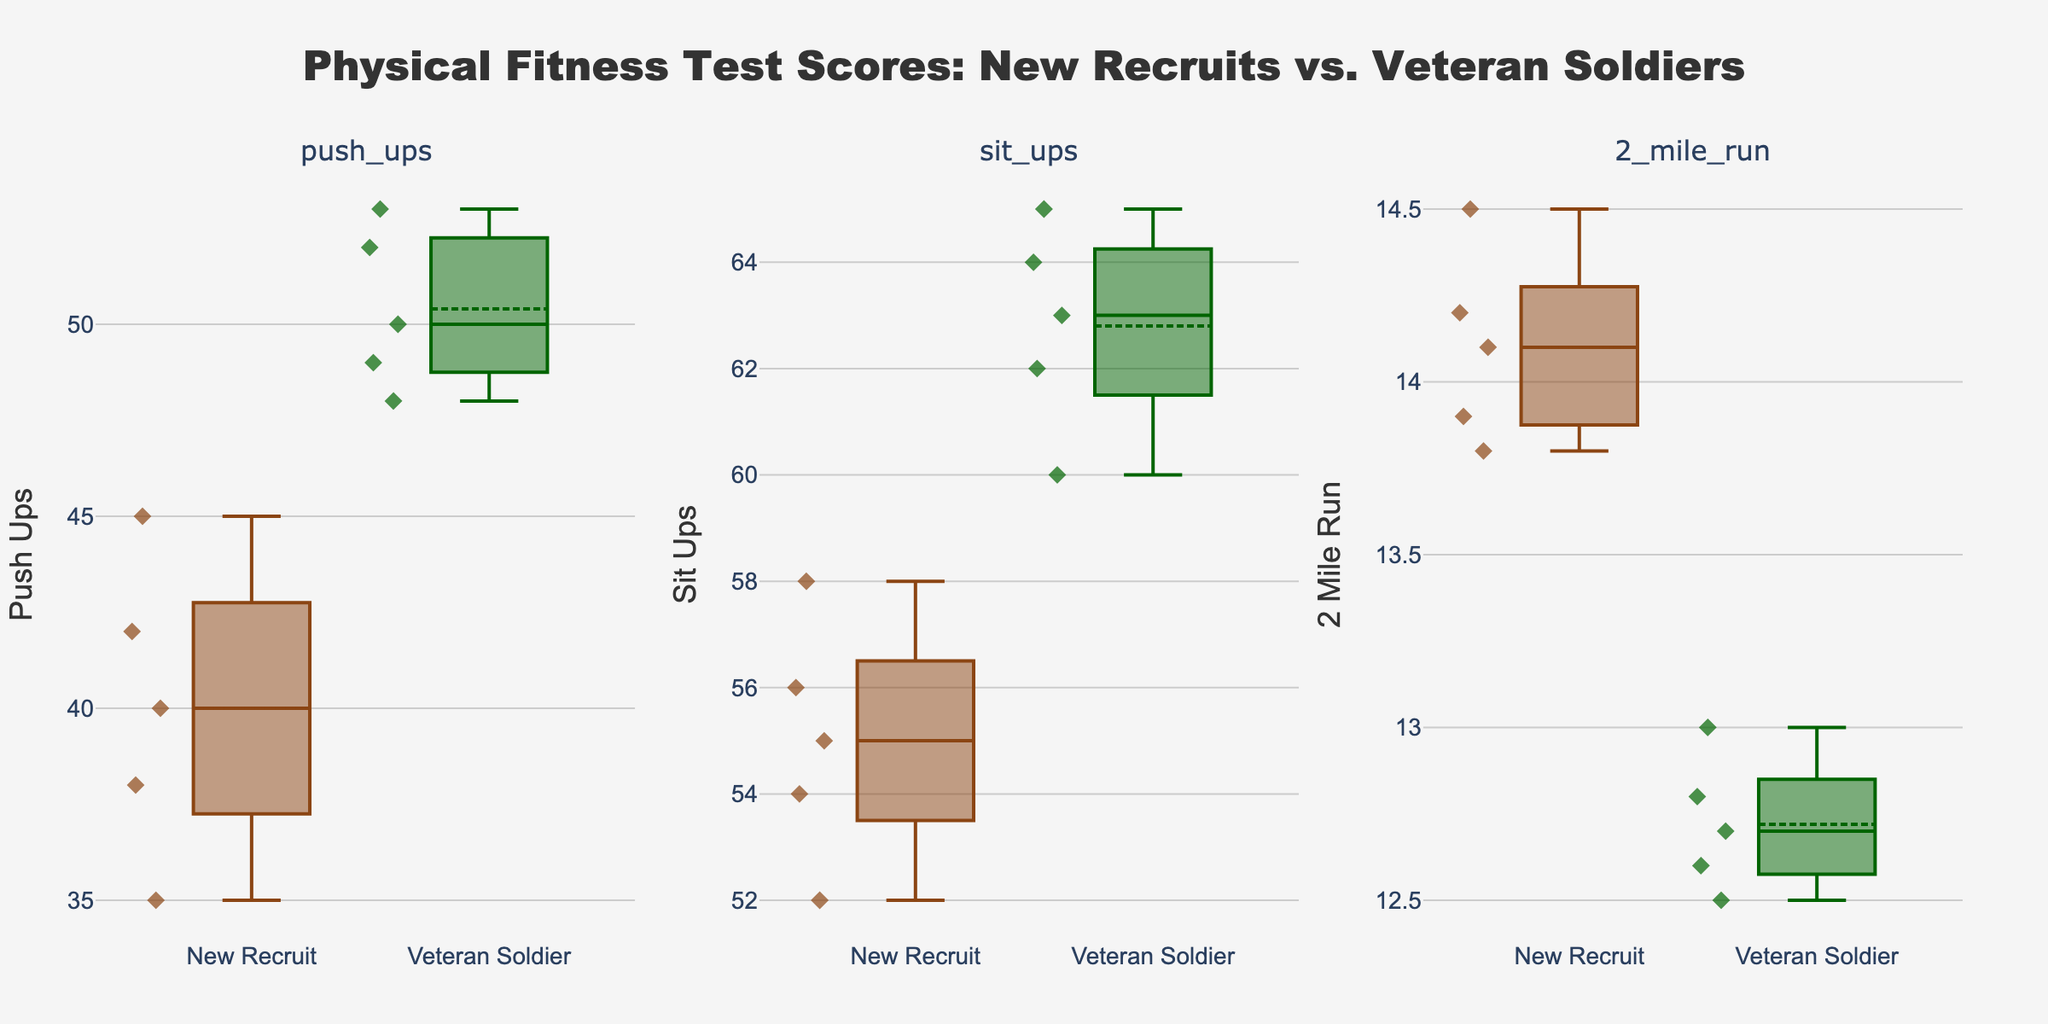What is the main title of the plot? The title is clearly displayed at the top of the plot. It reads "Physical Fitness Test Scores: New Recruits vs. Veteran Soldiers."
Answer: Physical Fitness Test Scores: New Recruits vs. Veteran Soldiers What categories are compared in the grouped box plot? The subplot titles show the categories being compared: push_ups, sit_ups, and 2_mile_run.
Answer: push_ups, sit_ups, 2_mile_run How many data points are there in the "Veteran Soldier" group for the "push_ups" category? By counting the individual points shown in the box plot for the "Veteran Soldier" group under the "push_ups" subplot, there are 5 points.
Answer: 5 Which group has the higher median value for "2_mile_run"? The median is indicated by the line inside each box plot. For the "2_mile_run" category, you can compare the line's position in each group. The "New Recruit" group has a higher median, as the line is at a higher y-axis value.
Answer: New Recruit What is the range of push-ups performed by the "New Recruit" group? The range is determined by the lower and upper whiskers of the box plot. In the "push_ups" category, the "New Recruit" group's whiskers extend from approximately 35 to 45 push-ups.
Answer: 35 to 45 How do the average times for "2_mile_run" compare between the two groups? Each box plot shows a small marker for the mean. By comparing these markers in the "2_mile_run" subplot, the mean time for the "New Recruit" group is slightly higher than for the "Veteran Soldier" group.
Answer: New Recruit has a higher average Among the groups for each test category, which has the smallest interquartile range (IQR) for sit-ups? The IQR is the distance between the first and third quartiles (the edges of each box). For the "sit_ups" category, the "New Recruit" group has a smaller box, indicating a smaller IQR.
Answer: New Recruit Which group has an outlier in the "push_ups" category? Outliers are indicated by points outside the whiskers. In the "push_ups" category, there are no points outside the whiskers for either group; hence, no outliers.
Answer: None Who has the higher maximum value for "sit_ups"? The maximum value is indicated by the upper whisker. For the "sit_ups" category, the "Veteran Soldier" group has a higher maximum value, as the whisker extends higher on the y-axis.
Answer: Veteran Soldier What is the median value for the "New Recruit" group's "sit_ups"? The median is represented by the line inside the box. For the "New Recruit" group in the "sit_ups" category, the median line is at 55.
Answer: 55 